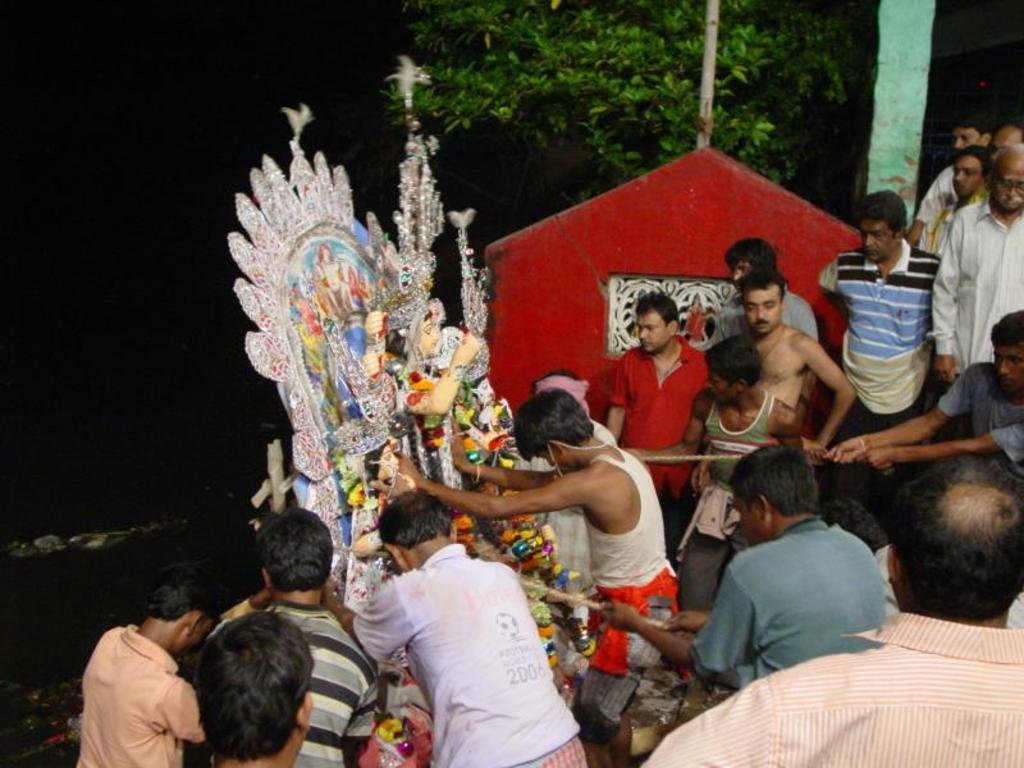What is the main subject of the image? The main subject of the image is a group of persons standing in the center. Are there any other objects or structures in the image? Yes, there is a statue and a tree in the background. What is the color of the wall in the background? The wall is red in color. What is the weight of the box that the persons are carrying in the image? There is no box visible in the image, and the persons are not carrying anything. 